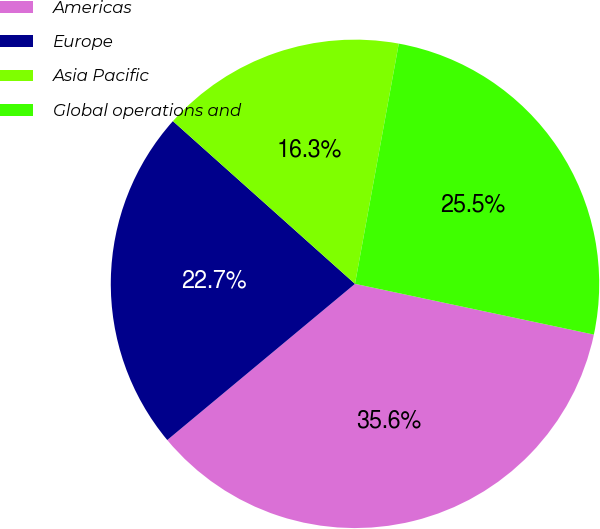Convert chart. <chart><loc_0><loc_0><loc_500><loc_500><pie_chart><fcel>Americas<fcel>Europe<fcel>Asia Pacific<fcel>Global operations and<nl><fcel>35.62%<fcel>22.65%<fcel>16.26%<fcel>25.46%<nl></chart> 